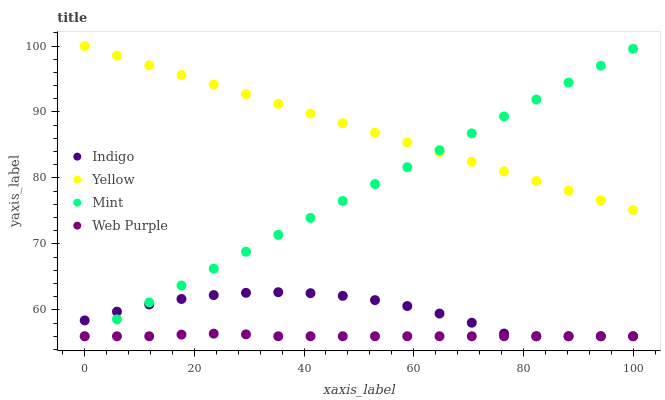Does Web Purple have the minimum area under the curve?
Answer yes or no. Yes. Does Yellow have the maximum area under the curve?
Answer yes or no. Yes. Does Indigo have the minimum area under the curve?
Answer yes or no. No. Does Indigo have the maximum area under the curve?
Answer yes or no. No. Is Yellow the smoothest?
Answer yes or no. Yes. Is Indigo the roughest?
Answer yes or no. Yes. Is Web Purple the smoothest?
Answer yes or no. No. Is Web Purple the roughest?
Answer yes or no. No. Does Mint have the lowest value?
Answer yes or no. Yes. Does Yellow have the lowest value?
Answer yes or no. No. Does Yellow have the highest value?
Answer yes or no. Yes. Does Indigo have the highest value?
Answer yes or no. No. Is Web Purple less than Yellow?
Answer yes or no. Yes. Is Yellow greater than Indigo?
Answer yes or no. Yes. Does Yellow intersect Mint?
Answer yes or no. Yes. Is Yellow less than Mint?
Answer yes or no. No. Is Yellow greater than Mint?
Answer yes or no. No. Does Web Purple intersect Yellow?
Answer yes or no. No. 